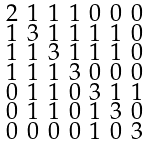<formula> <loc_0><loc_0><loc_500><loc_500>\begin{smallmatrix} 2 & 1 & 1 & 1 & 0 & 0 & 0 \\ 1 & 3 & 1 & 1 & 1 & 1 & 0 \\ 1 & 1 & 3 & 1 & 1 & 1 & 0 \\ 1 & 1 & 1 & 3 & 0 & 0 & 0 \\ 0 & 1 & 1 & 0 & 3 & 1 & 1 \\ 0 & 1 & 1 & 0 & 1 & 3 & 0 \\ 0 & 0 & 0 & 0 & 1 & 0 & 3 \end{smallmatrix}</formula> 